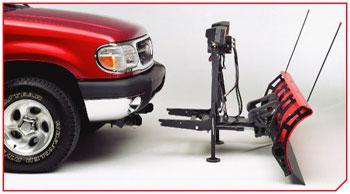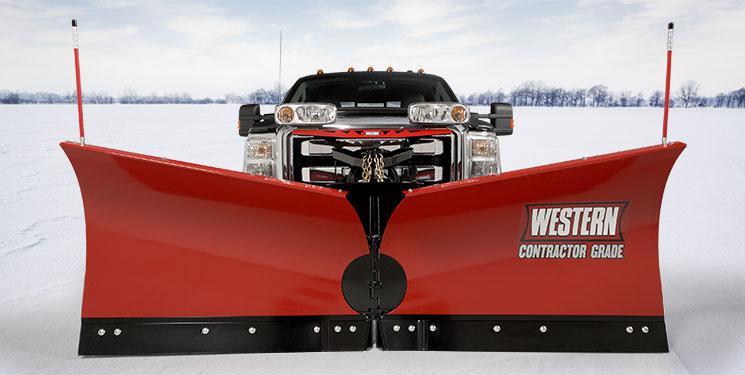The first image is the image on the left, the second image is the image on the right. Analyze the images presented: Is the assertion "There is exactly one scraper not attached to a vehicle in the image on the left" valid? Answer yes or no. Yes. The first image is the image on the left, the second image is the image on the right. For the images displayed, is the sentence "In each image, a snow plow blade is shown with a pickup truck." factually correct? Answer yes or no. Yes. 